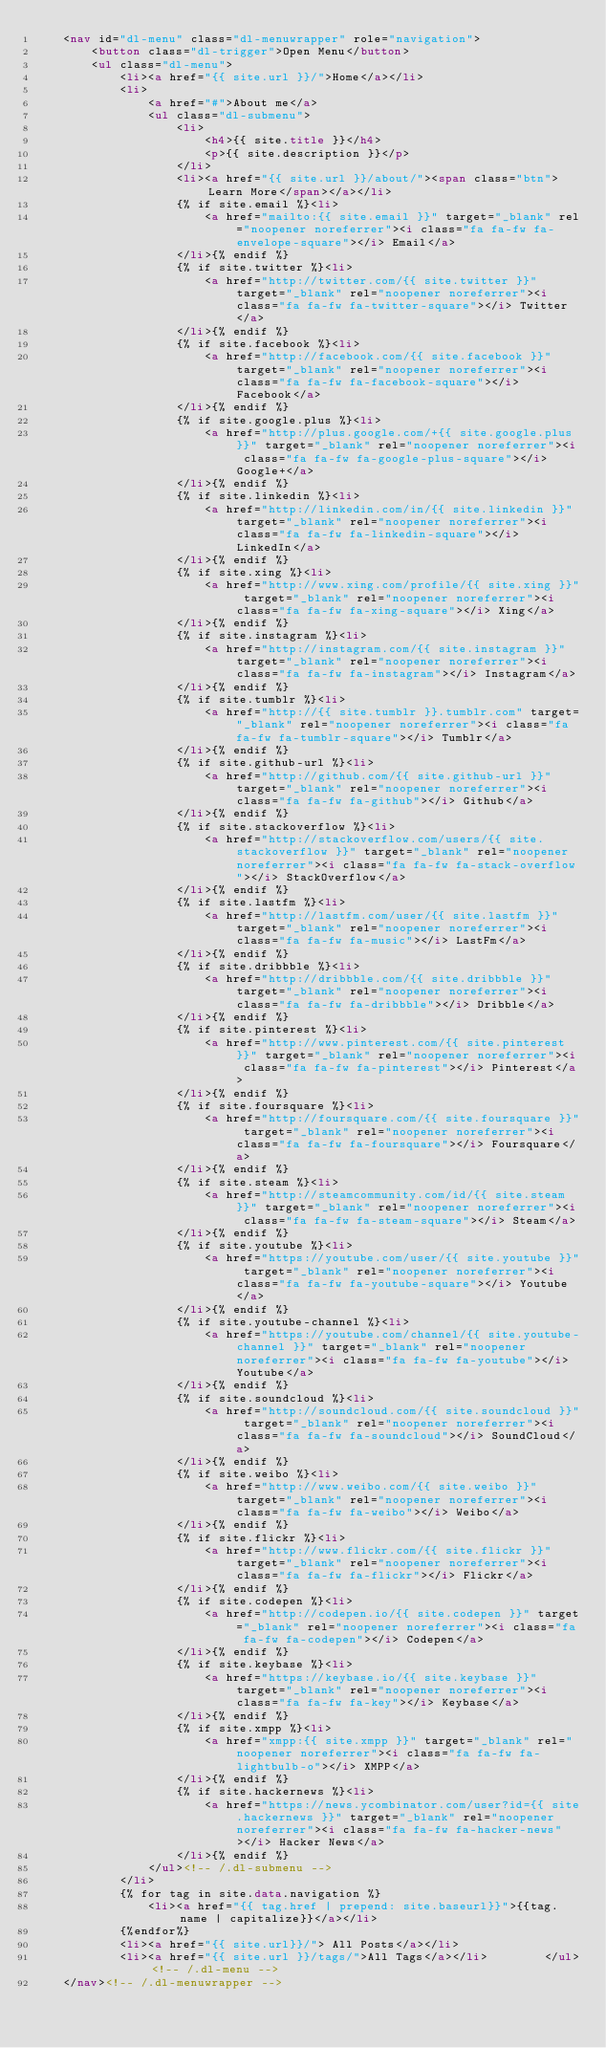Convert code to text. <code><loc_0><loc_0><loc_500><loc_500><_HTML_>	<nav id="dl-menu" class="dl-menuwrapper" role="navigation">
		<button class="dl-trigger">Open Menu</button>
		<ul class="dl-menu">
			<li><a href="{{ site.url }}/">Home</a></li>
			<li>
				<a href="#">About me</a>
				<ul class="dl-submenu">
					<li>
						<h4>{{ site.title }}</h4>
						<p>{{ site.description }}</p>
					</li>
					<li><a href="{{ site.url }}/about/"><span class="btn">Learn More</span></a></li>
					{% if site.email %}<li>
                        <a href="mailto:{{ site.email }}" target="_blank" rel="noopener noreferrer"><i class="fa fa-fw fa-envelope-square"></i> Email</a>
                    </li>{% endif %}
                    {% if site.twitter %}<li>
                        <a href="http://twitter.com/{{ site.twitter }}" target="_blank" rel="noopener noreferrer"><i class="fa fa-fw fa-twitter-square"></i> Twitter</a>
                    </li>{% endif %}
                    {% if site.facebook %}<li>
                        <a href="http://facebook.com/{{ site.facebook }}" target="_blank" rel="noopener noreferrer"><i class="fa fa-fw fa-facebook-square"></i> Facebook</a>
                    </li>{% endif %}
                    {% if site.google.plus %}<li>
                        <a href="http://plus.google.com/+{{ site.google.plus }}" target="_blank" rel="noopener noreferrer"><i class="fa fa-fw fa-google-plus-square"></i> Google+</a>
                    </li>{% endif %}
                    {% if site.linkedin %}<li>
                        <a href="http://linkedin.com/in/{{ site.linkedin }}" target="_blank" rel="noopener noreferrer"><i class="fa fa-fw fa-linkedin-square"></i> LinkedIn</a>
                    </li>{% endif %}
                    {% if site.xing %}<li>
                        <a href="http://www.xing.com/profile/{{ site.xing }}" target="_blank" rel="noopener noreferrer"><i class="fa fa-fw fa-xing-square"></i> Xing</a>
                    </li>{% endif %}
                    {% if site.instagram %}<li>
                        <a href="http://instagram.com/{{ site.instagram }}" target="_blank" rel="noopener noreferrer"><i class="fa fa-fw fa-instagram"></i> Instagram</a>
                    </li>{% endif %}
                    {% if site.tumblr %}<li>
                        <a href="http://{{ site.tumblr }}.tumblr.com" target="_blank" rel="noopener noreferrer"><i class="fa fa-fw fa-tumblr-square"></i> Tumblr</a>
                    </li>{% endif %}
                    {% if site.github-url %}<li>
                        <a href="http://github.com/{{ site.github-url }}" target="_blank" rel="noopener noreferrer"><i class="fa fa-fw fa-github"></i> Github</a>
                    </li>{% endif %}
                    {% if site.stackoverflow %}<li>
                        <a href="http://stackoverflow.com/users/{{ site.stackoverflow }}" target="_blank" rel="noopener noreferrer"><i class="fa fa-fw fa-stack-overflow"></i> StackOverflow</a>
                    </li>{% endif %}
                    {% if site.lastfm %}<li>
                        <a href="http://lastfm.com/user/{{ site.lastfm }}" target="_blank" rel="noopener noreferrer"><i class="fa fa-fw fa-music"></i> LastFm</a>
                    </li>{% endif %}
                    {% if site.dribbble %}<li>
                        <a href="http://dribbble.com/{{ site.dribbble }}" target="_blank" rel="noopener noreferrer"><i class="fa fa-fw fa-dribbble"></i> Dribble</a>
                    </li>{% endif %}
                    {% if site.pinterest %}<li>
                        <a href="http://www.pinterest.com/{{ site.pinterest }}" target="_blank" rel="noopener noreferrer"><i class="fa fa-fw fa-pinterest"></i> Pinterest</a>
                    </li>{% endif %}
                    {% if site.foursquare %}<li>
                        <a href="http://foursquare.com/{{ site.foursquare }}" target="_blank" rel="noopener noreferrer"><i class="fa fa-fw fa-foursquare"></i> Foursquare</a>
                    </li>{% endif %}
                    {% if site.steam %}<li>
                        <a href="http://steamcommunity.com/id/{{ site.steam }}" target="_blank" rel="noopener noreferrer"><i class="fa fa-fw fa-steam-square"></i> Steam</a>
                    </li>{% endif %}
                    {% if site.youtube %}<li>
                        <a href="https://youtube.com/user/{{ site.youtube }}" target="_blank" rel="noopener noreferrer"><i class="fa fa-fw fa-youtube-square"></i> Youtube</a>
                    </li>{% endif %}
                    {% if site.youtube-channel %}<li>
                        <a href="https://youtube.com/channel/{{ site.youtube-channel }}" target="_blank" rel="noopener noreferrer"><i class="fa fa-fw fa-youtube"></i> Youtube</a>
                    </li>{% endif %}
                    {% if site.soundcloud %}<li>
                        <a href="http://soundcloud.com/{{ site.soundcloud }}" target="_blank" rel="noopener noreferrer"><i class="fa fa-fw fa-soundcloud"></i> SoundCloud</a>
                    </li>{% endif %}
                    {% if site.weibo %}<li>
                        <a href="http://www.weibo.com/{{ site.weibo }}" target="_blank" rel="noopener noreferrer"><i class="fa fa-fw fa-weibo"></i> Weibo</a>
                    </li>{% endif %}
                    {% if site.flickr %}<li>
                        <a href="http://www.flickr.com/{{ site.flickr }}" target="_blank" rel="noopener noreferrer"><i class="fa fa-fw fa-flickr"></i> Flickr</a>
                    </li>{% endif %}
                    {% if site.codepen %}<li>
                        <a href="http://codepen.io/{{ site.codepen }}" target="_blank" rel="noopener noreferrer"><i class="fa fa-fw fa-codepen"></i> Codepen</a>
                    </li>{% endif %}
                    {% if site.keybase %}<li>
                        <a href="https://keybase.io/{{ site.keybase }}" target="_blank" rel="noopener noreferrer"><i class="fa fa-fw fa-key"></i> Keybase</a>
                    </li>{% endif %}
                    {% if site.xmpp %}<li>
                        <a href="xmpp:{{ site.xmpp }}" target="_blank" rel="noopener noreferrer"><i class="fa fa-fw fa-lightbulb-o"></i> XMPP</a>
                    </li>{% endif %}
                    {% if site.hackernews %}<li>
                        <a href="https://news.ycombinator.com/user?id={{ site.hackernews }}" target="_blank" rel="noopener noreferrer"><i class="fa fa-fw fa-hacker-news"></i> Hacker News</a>
                    </li>{% endif %}
				</ul><!-- /.dl-submenu -->
            </li>
            {% for tag in site.data.navigation %}
                <li><a href="{{ tag.href | prepend: site.baseurl}}">{{tag.name | capitalize}}</a></li>
            {%endfor%}
            <li><a href="{{ site.url}}/"> All Posts</a></li>
			<li><a href="{{ site.url }}/tags/">All Tags</a></li>		</ul><!-- /.dl-menu -->
	</nav><!-- /.dl-menuwrapper -->
</code> 